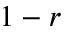Convert formula to latex. <formula><loc_0><loc_0><loc_500><loc_500>1 - r</formula> 